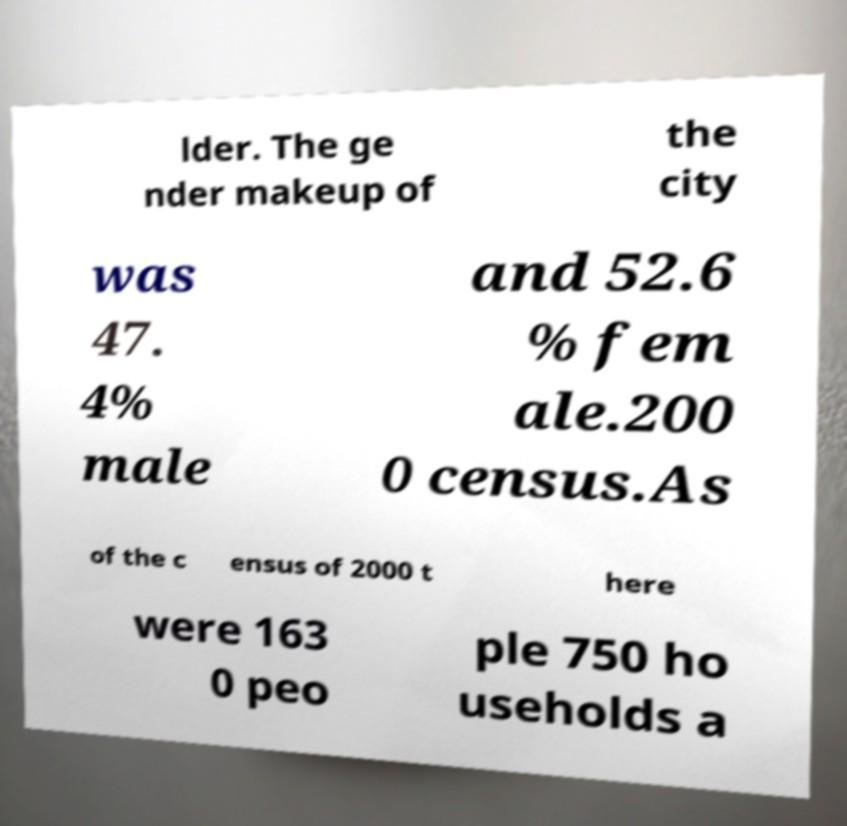There's text embedded in this image that I need extracted. Can you transcribe it verbatim? lder. The ge nder makeup of the city was 47. 4% male and 52.6 % fem ale.200 0 census.As of the c ensus of 2000 t here were 163 0 peo ple 750 ho useholds a 